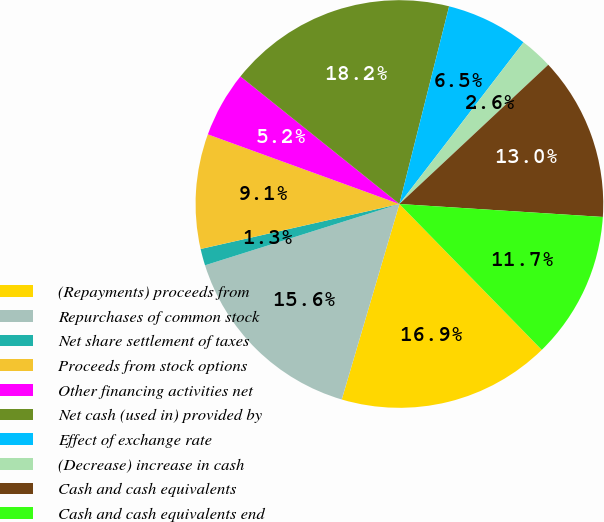Convert chart to OTSL. <chart><loc_0><loc_0><loc_500><loc_500><pie_chart><fcel>(Repayments) proceeds from<fcel>Repurchases of common stock<fcel>Net share settlement of taxes<fcel>Proceeds from stock options<fcel>Other financing activities net<fcel>Net cash (used in) provided by<fcel>Effect of exchange rate<fcel>(Decrease) increase in cash<fcel>Cash and cash equivalents<fcel>Cash and cash equivalents end<nl><fcel>16.87%<fcel>15.57%<fcel>1.32%<fcel>9.09%<fcel>5.21%<fcel>18.16%<fcel>6.5%<fcel>2.61%<fcel>12.98%<fcel>11.68%<nl></chart> 